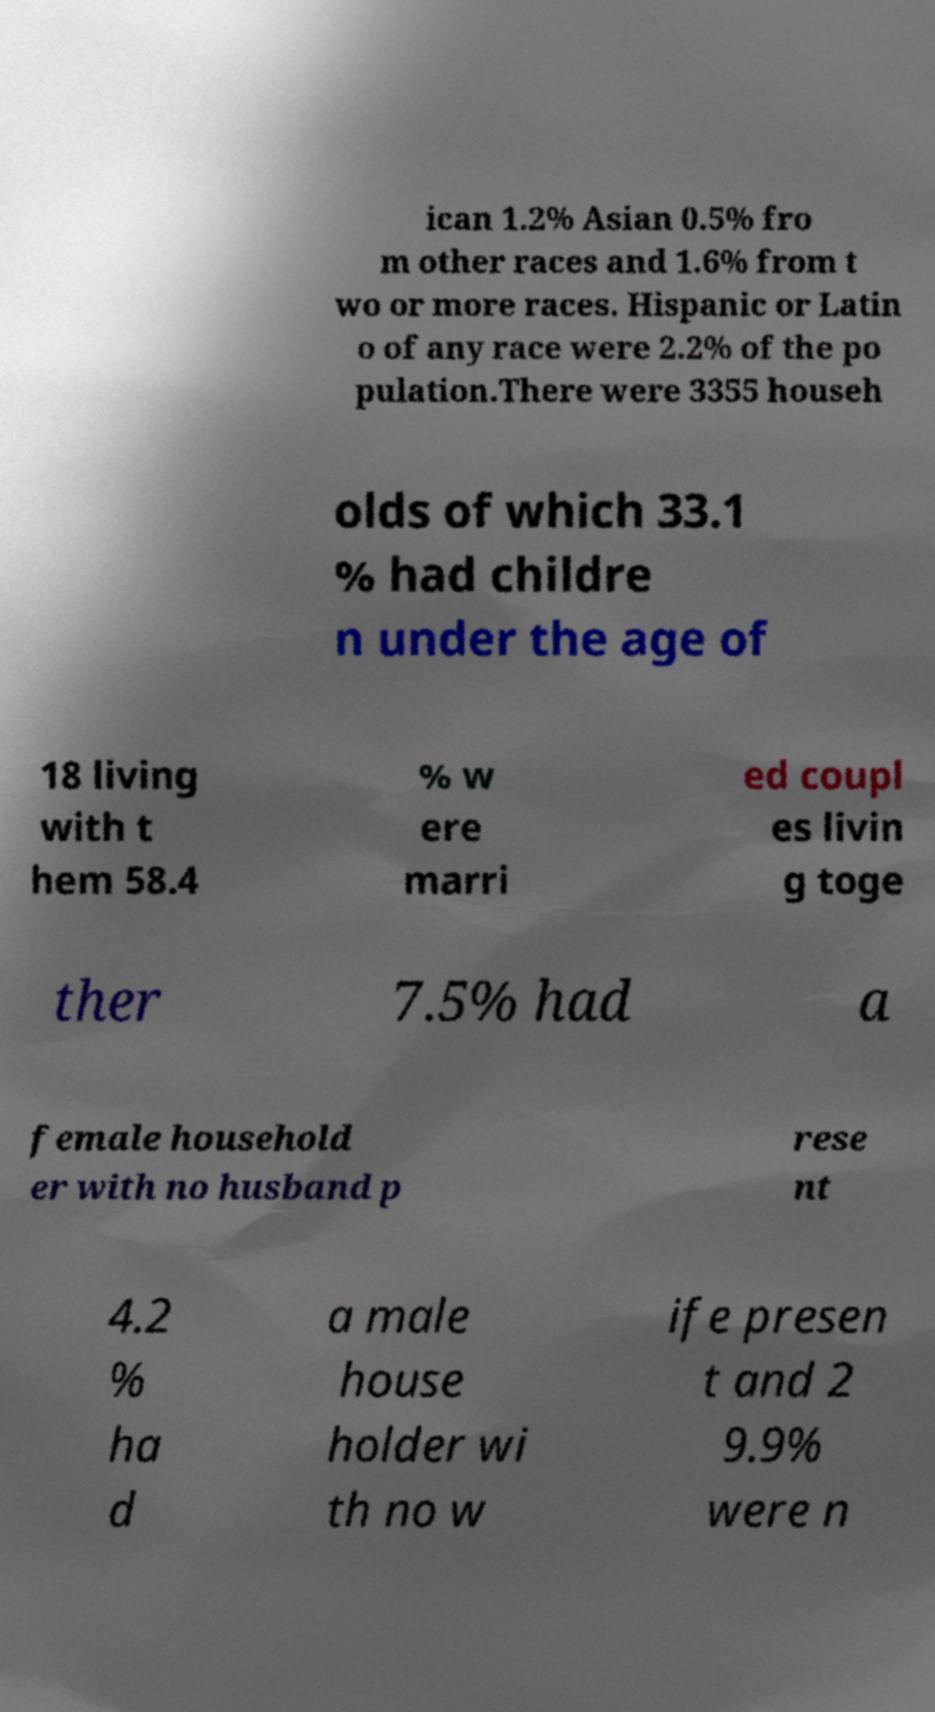Please read and relay the text visible in this image. What does it say? ican 1.2% Asian 0.5% fro m other races and 1.6% from t wo or more races. Hispanic or Latin o of any race were 2.2% of the po pulation.There were 3355 househ olds of which 33.1 % had childre n under the age of 18 living with t hem 58.4 % w ere marri ed coupl es livin g toge ther 7.5% had a female household er with no husband p rese nt 4.2 % ha d a male house holder wi th no w ife presen t and 2 9.9% were n 